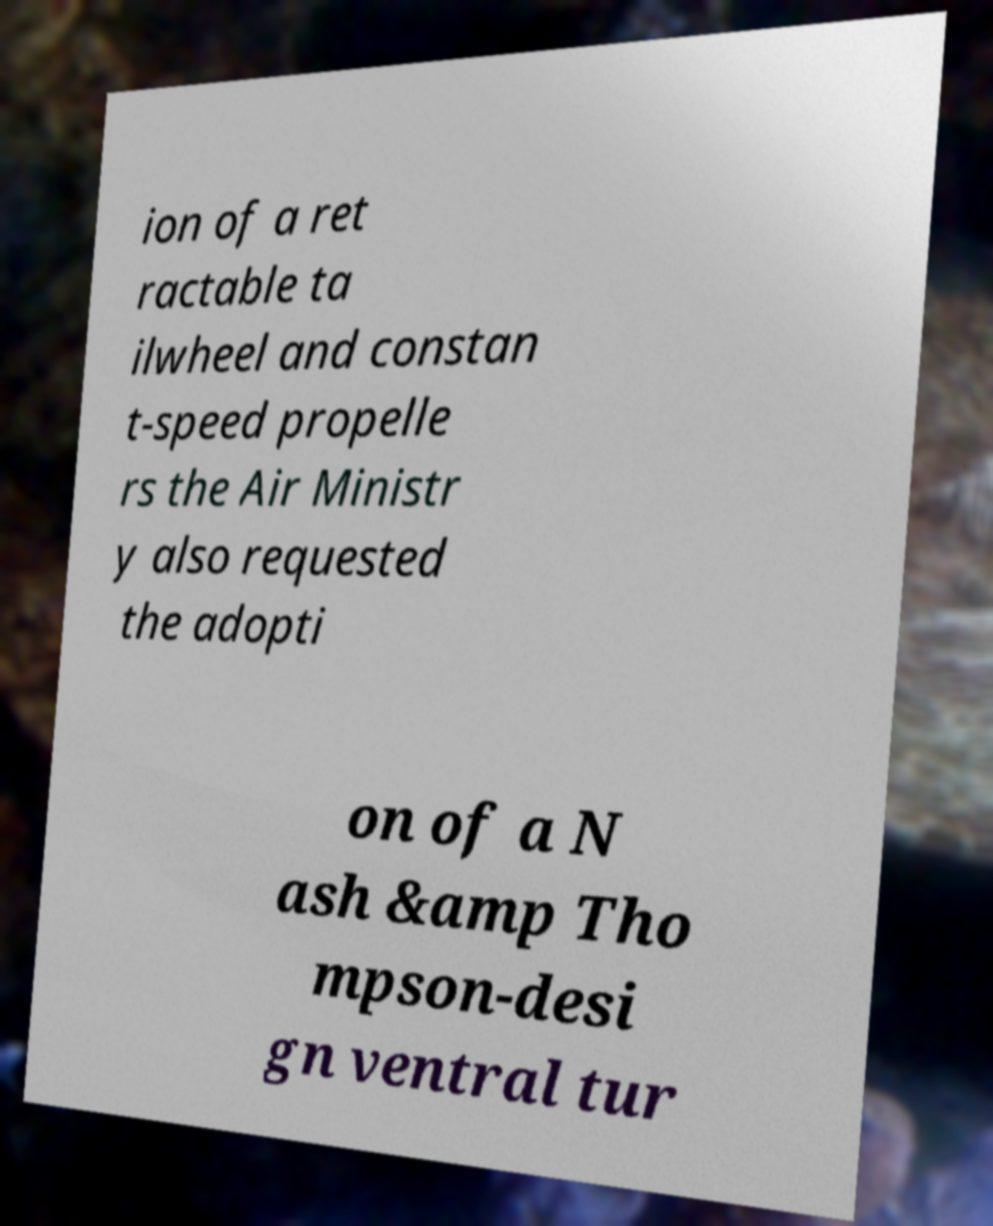Please identify and transcribe the text found in this image. ion of a ret ractable ta ilwheel and constan t-speed propelle rs the Air Ministr y also requested the adopti on of a N ash &amp Tho mpson-desi gn ventral tur 